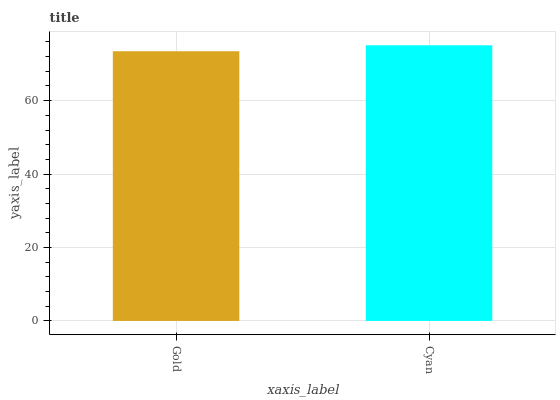Is Gold the minimum?
Answer yes or no. Yes. Is Cyan the maximum?
Answer yes or no. Yes. Is Cyan the minimum?
Answer yes or no. No. Is Cyan greater than Gold?
Answer yes or no. Yes. Is Gold less than Cyan?
Answer yes or no. Yes. Is Gold greater than Cyan?
Answer yes or no. No. Is Cyan less than Gold?
Answer yes or no. No. Is Cyan the high median?
Answer yes or no. Yes. Is Gold the low median?
Answer yes or no. Yes. Is Gold the high median?
Answer yes or no. No. Is Cyan the low median?
Answer yes or no. No. 